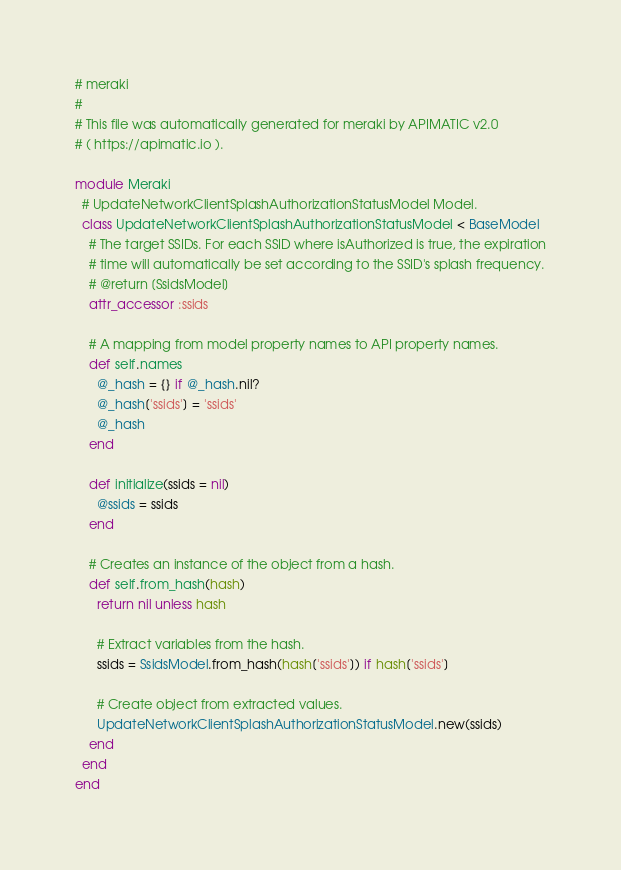Convert code to text. <code><loc_0><loc_0><loc_500><loc_500><_Ruby_># meraki
#
# This file was automatically generated for meraki by APIMATIC v2.0
# ( https://apimatic.io ).

module Meraki
  # UpdateNetworkClientSplashAuthorizationStatusModel Model.
  class UpdateNetworkClientSplashAuthorizationStatusModel < BaseModel
    # The target SSIDs. For each SSID where isAuthorized is true, the expiration
    # time will automatically be set according to the SSID's splash frequency.
    # @return [SsidsModel]
    attr_accessor :ssids

    # A mapping from model property names to API property names.
    def self.names
      @_hash = {} if @_hash.nil?
      @_hash['ssids'] = 'ssids'
      @_hash
    end

    def initialize(ssids = nil)
      @ssids = ssids
    end

    # Creates an instance of the object from a hash.
    def self.from_hash(hash)
      return nil unless hash

      # Extract variables from the hash.
      ssids = SsidsModel.from_hash(hash['ssids']) if hash['ssids']

      # Create object from extracted values.
      UpdateNetworkClientSplashAuthorizationStatusModel.new(ssids)
    end
  end
end
</code> 